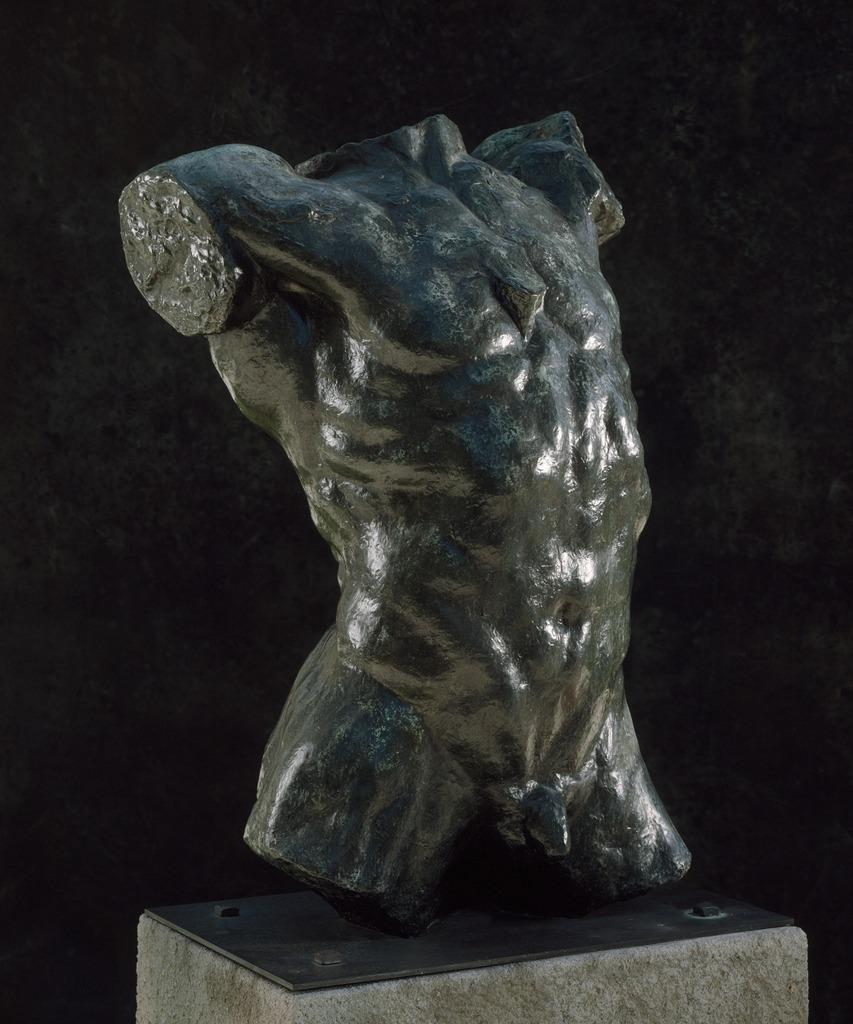What is the main subject of the image? There is a sculpture in the image. Can you describe the background of the image? The background of the image is dark. What thoughts are the kittens having while sitting on the sculpture in the image? There are no kittens present in the image, so it is not possible to determine their thoughts. 